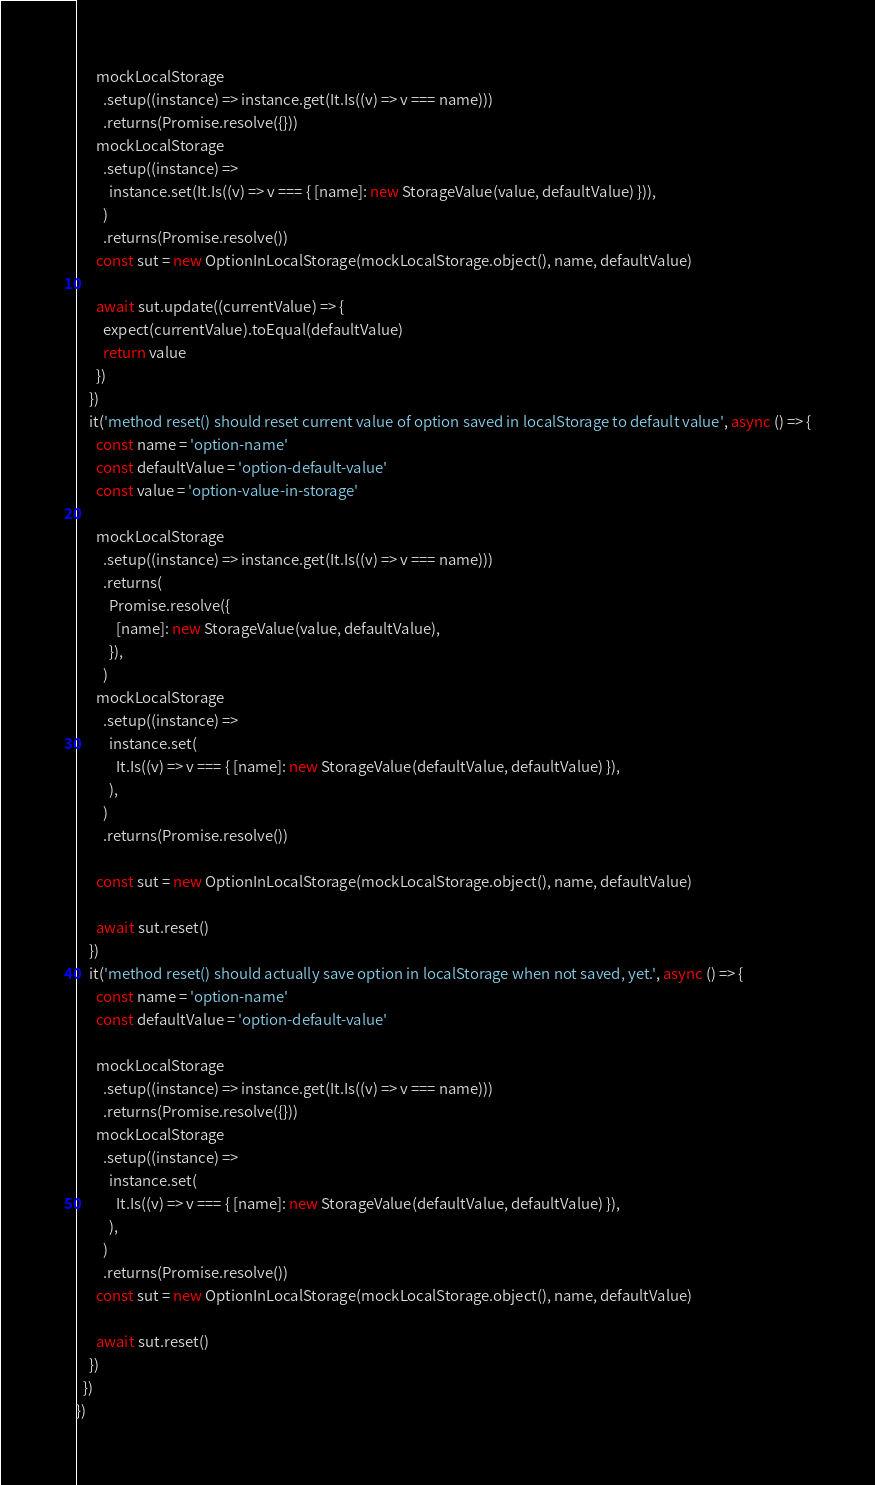<code> <loc_0><loc_0><loc_500><loc_500><_TypeScript_>
      mockLocalStorage
        .setup((instance) => instance.get(It.Is((v) => v === name)))
        .returns(Promise.resolve({}))
      mockLocalStorage
        .setup((instance) =>
          instance.set(It.Is((v) => v === { [name]: new StorageValue(value, defaultValue) })),
        )
        .returns(Promise.resolve())
      const sut = new OptionInLocalStorage(mockLocalStorage.object(), name, defaultValue)

      await sut.update((currentValue) => {
        expect(currentValue).toEqual(defaultValue)
        return value
      })
    })
    it('method reset() should reset current value of option saved in localStorage to default value', async () => {
      const name = 'option-name'
      const defaultValue = 'option-default-value'
      const value = 'option-value-in-storage'

      mockLocalStorage
        .setup((instance) => instance.get(It.Is((v) => v === name)))
        .returns(
          Promise.resolve({
            [name]: new StorageValue(value, defaultValue),
          }),
        )
      mockLocalStorage
        .setup((instance) =>
          instance.set(
            It.Is((v) => v === { [name]: new StorageValue(defaultValue, defaultValue) }),
          ),
        )
        .returns(Promise.resolve())

      const sut = new OptionInLocalStorage(mockLocalStorage.object(), name, defaultValue)

      await sut.reset()
    })
    it('method reset() should actually save option in localStorage when not saved, yet.', async () => {
      const name = 'option-name'
      const defaultValue = 'option-default-value'

      mockLocalStorage
        .setup((instance) => instance.get(It.Is((v) => v === name)))
        .returns(Promise.resolve({}))
      mockLocalStorage
        .setup((instance) =>
          instance.set(
            It.Is((v) => v === { [name]: new StorageValue(defaultValue, defaultValue) }),
          ),
        )
        .returns(Promise.resolve())
      const sut = new OptionInLocalStorage(mockLocalStorage.object(), name, defaultValue)

      await sut.reset()
    })
  })
})
</code> 